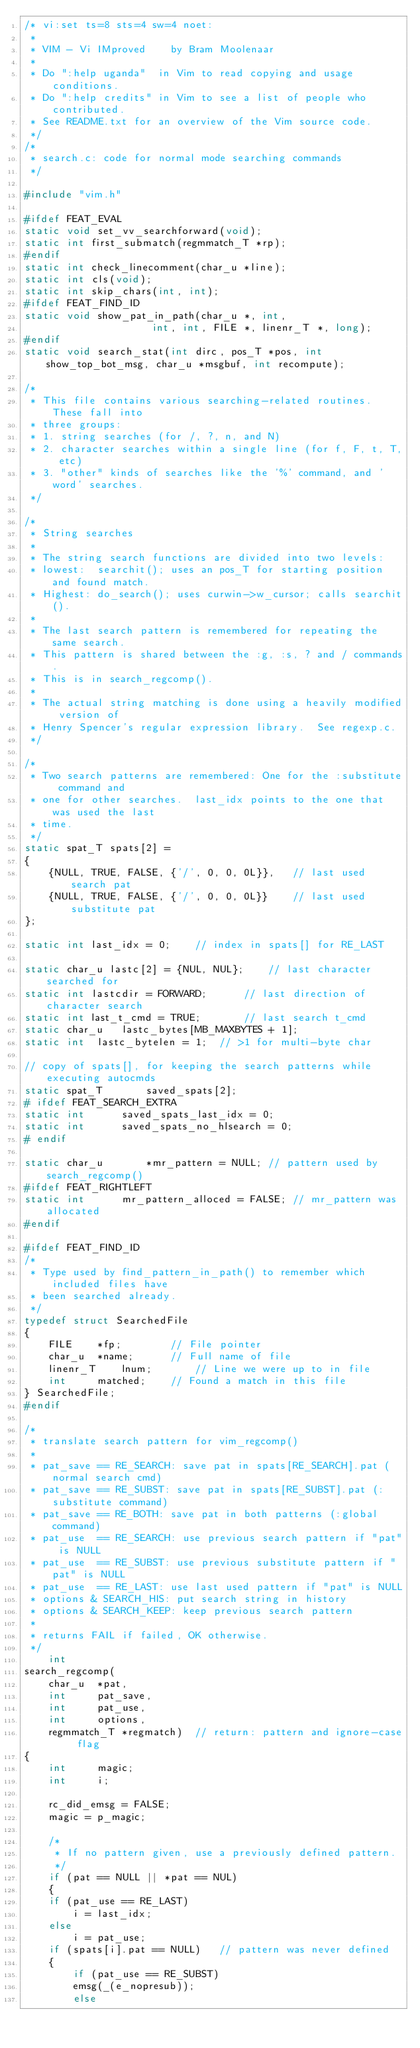<code> <loc_0><loc_0><loc_500><loc_500><_C_>/* vi:set ts=8 sts=4 sw=4 noet:
 *
 * VIM - Vi IMproved	by Bram Moolenaar
 *
 * Do ":help uganda"  in Vim to read copying and usage conditions.
 * Do ":help credits" in Vim to see a list of people who contributed.
 * See README.txt for an overview of the Vim source code.
 */
/*
 * search.c: code for normal mode searching commands
 */

#include "vim.h"

#ifdef FEAT_EVAL
static void set_vv_searchforward(void);
static int first_submatch(regmmatch_T *rp);
#endif
static int check_linecomment(char_u *line);
static int cls(void);
static int skip_chars(int, int);
#ifdef FEAT_FIND_ID
static void show_pat_in_path(char_u *, int,
					 int, int, FILE *, linenr_T *, long);
#endif
static void search_stat(int dirc, pos_T *pos, int show_top_bot_msg, char_u *msgbuf, int recompute);

/*
 * This file contains various searching-related routines. These fall into
 * three groups:
 * 1. string searches (for /, ?, n, and N)
 * 2. character searches within a single line (for f, F, t, T, etc)
 * 3. "other" kinds of searches like the '%' command, and 'word' searches.
 */

/*
 * String searches
 *
 * The string search functions are divided into two levels:
 * lowest:  searchit(); uses an pos_T for starting position and found match.
 * Highest: do_search(); uses curwin->w_cursor; calls searchit().
 *
 * The last search pattern is remembered for repeating the same search.
 * This pattern is shared between the :g, :s, ? and / commands.
 * This is in search_regcomp().
 *
 * The actual string matching is done using a heavily modified version of
 * Henry Spencer's regular expression library.  See regexp.c.
 */

/*
 * Two search patterns are remembered: One for the :substitute command and
 * one for other searches.  last_idx points to the one that was used the last
 * time.
 */
static spat_T spats[2] =
{
    {NULL, TRUE, FALSE, {'/', 0, 0, 0L}},	// last used search pat
    {NULL, TRUE, FALSE, {'/', 0, 0, 0L}}	// last used substitute pat
};

static int last_idx = 0;	// index in spats[] for RE_LAST

static char_u lastc[2] = {NUL, NUL};	// last character searched for
static int lastcdir = FORWARD;		// last direction of character search
static int last_t_cmd = TRUE;		// last search t_cmd
static char_u	lastc_bytes[MB_MAXBYTES + 1];
static int	lastc_bytelen = 1;	// >1 for multi-byte char

// copy of spats[], for keeping the search patterns while executing autocmds
static spat_T	    saved_spats[2];
# ifdef FEAT_SEARCH_EXTRA
static int	    saved_spats_last_idx = 0;
static int	    saved_spats_no_hlsearch = 0;
# endif

static char_u	    *mr_pattern = NULL;	// pattern used by search_regcomp()
#ifdef FEAT_RIGHTLEFT
static int	    mr_pattern_alloced = FALSE; // mr_pattern was allocated
#endif

#ifdef FEAT_FIND_ID
/*
 * Type used by find_pattern_in_path() to remember which included files have
 * been searched already.
 */
typedef struct SearchedFile
{
    FILE	*fp;		// File pointer
    char_u	*name;		// Full name of file
    linenr_T	lnum;		// Line we were up to in file
    int		matched;	// Found a match in this file
} SearchedFile;
#endif

/*
 * translate search pattern for vim_regcomp()
 *
 * pat_save == RE_SEARCH: save pat in spats[RE_SEARCH].pat (normal search cmd)
 * pat_save == RE_SUBST: save pat in spats[RE_SUBST].pat (:substitute command)
 * pat_save == RE_BOTH: save pat in both patterns (:global command)
 * pat_use  == RE_SEARCH: use previous search pattern if "pat" is NULL
 * pat_use  == RE_SUBST: use previous substitute pattern if "pat" is NULL
 * pat_use  == RE_LAST: use last used pattern if "pat" is NULL
 * options & SEARCH_HIS: put search string in history
 * options & SEARCH_KEEP: keep previous search pattern
 *
 * returns FAIL if failed, OK otherwise.
 */
    int
search_regcomp(
    char_u	*pat,
    int		pat_save,
    int		pat_use,
    int		options,
    regmmatch_T	*regmatch)	// return: pattern and ignore-case flag
{
    int		magic;
    int		i;

    rc_did_emsg = FALSE;
    magic = p_magic;

    /*
     * If no pattern given, use a previously defined pattern.
     */
    if (pat == NULL || *pat == NUL)
    {
	if (pat_use == RE_LAST)
	    i = last_idx;
	else
	    i = pat_use;
	if (spats[i].pat == NULL)	// pattern was never defined
	{
	    if (pat_use == RE_SUBST)
		emsg(_(e_nopresub));
	    else</code> 